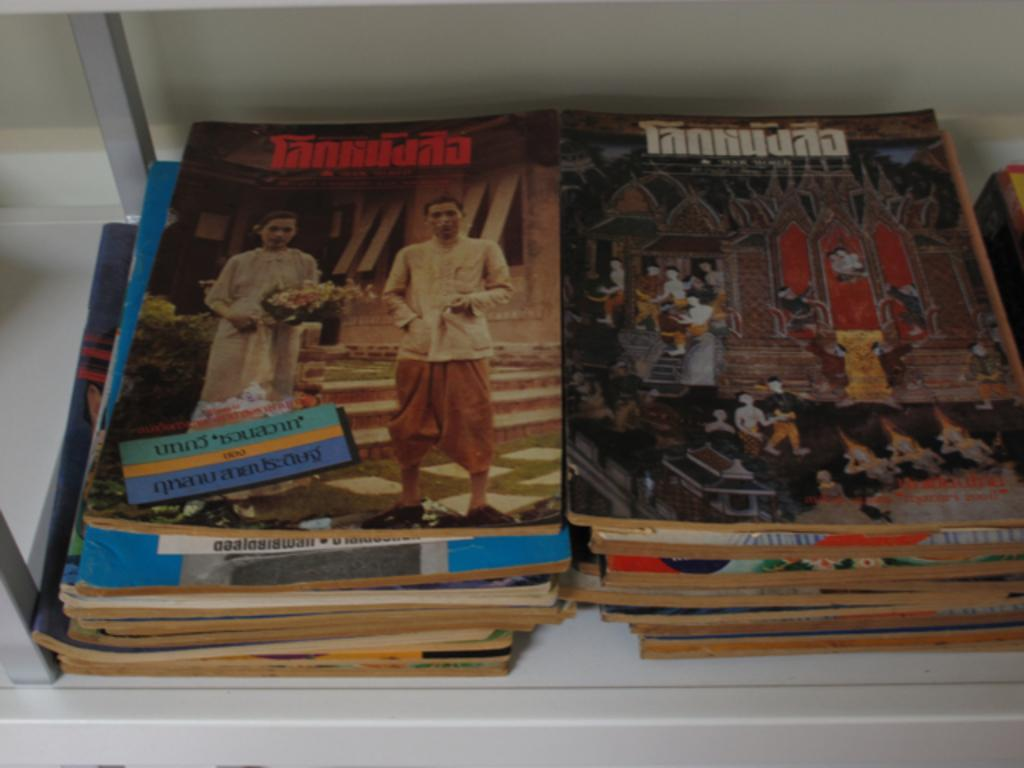What is the main subject of the image? The main subject of the image is many books. What is the color of the surface on which the books are placed? The books are on a white surface. What can be seen on the covers of the books? The books have images of persons on them. What is present on the books besides the images? There is writing on the books. What type of weather can be seen in the image? There is no weather depicted in the image, as it features books on a white surface. Can you tell me how many mothers are present in the image? There are no mothers present in the image; it features books with images of persons. 